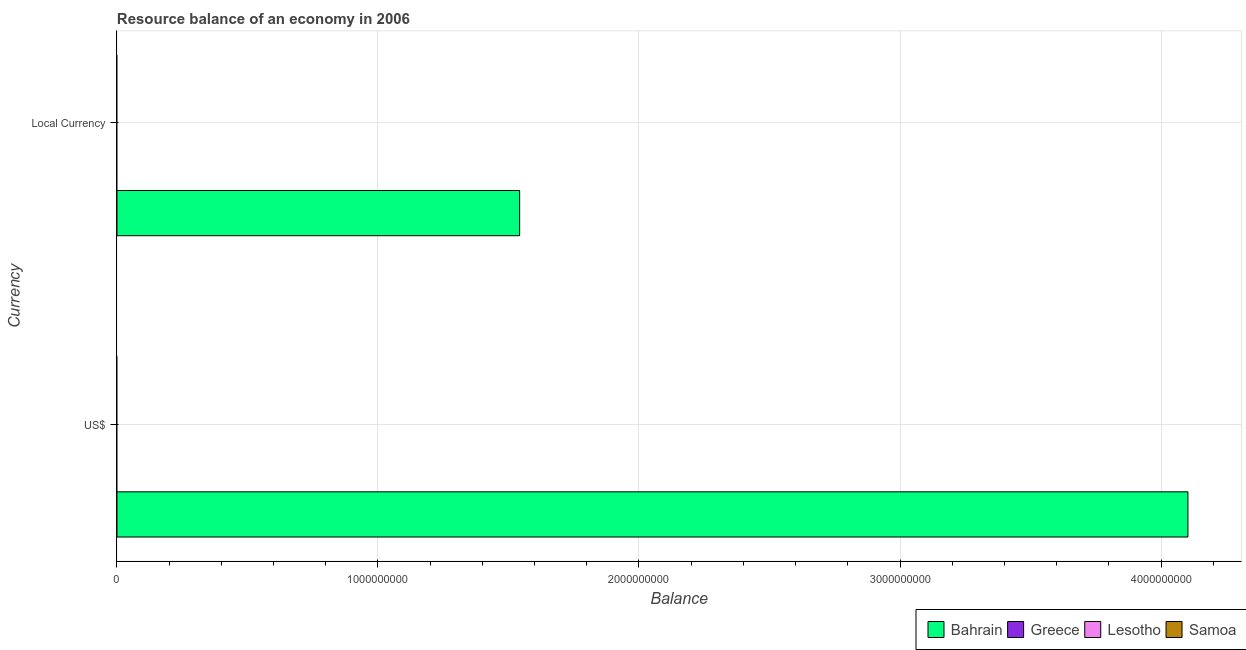How many different coloured bars are there?
Offer a terse response. 1. Are the number of bars on each tick of the Y-axis equal?
Your answer should be very brief. Yes. What is the label of the 1st group of bars from the top?
Make the answer very short. Local Currency. What is the resource balance in constant us$ in Greece?
Make the answer very short. 0. Across all countries, what is the maximum resource balance in constant us$?
Ensure brevity in your answer.  1.54e+09. Across all countries, what is the minimum resource balance in constant us$?
Keep it short and to the point. 0. In which country was the resource balance in us$ maximum?
Ensure brevity in your answer.  Bahrain. What is the total resource balance in us$ in the graph?
Your response must be concise. 4.10e+09. What is the difference between the resource balance in us$ in Greece and the resource balance in constant us$ in Bahrain?
Offer a very short reply. -1.54e+09. What is the average resource balance in us$ per country?
Ensure brevity in your answer.  1.03e+09. What is the difference between the resource balance in constant us$ and resource balance in us$ in Bahrain?
Ensure brevity in your answer.  -2.56e+09. In how many countries, is the resource balance in us$ greater than 3200000000 units?
Your response must be concise. 1. In how many countries, is the resource balance in constant us$ greater than the average resource balance in constant us$ taken over all countries?
Ensure brevity in your answer.  1. How many bars are there?
Provide a succinct answer. 2. Are all the bars in the graph horizontal?
Your answer should be compact. Yes. How many countries are there in the graph?
Offer a very short reply. 4. What is the difference between two consecutive major ticks on the X-axis?
Offer a terse response. 1.00e+09. Does the graph contain any zero values?
Ensure brevity in your answer.  Yes. Where does the legend appear in the graph?
Keep it short and to the point. Bottom right. What is the title of the graph?
Make the answer very short. Resource balance of an economy in 2006. What is the label or title of the X-axis?
Keep it short and to the point. Balance. What is the label or title of the Y-axis?
Your answer should be very brief. Currency. What is the Balance of Bahrain in US$?
Ensure brevity in your answer.  4.10e+09. What is the Balance in Greece in US$?
Your answer should be very brief. 0. What is the Balance in Lesotho in US$?
Offer a terse response. 0. What is the Balance of Samoa in US$?
Your response must be concise. 0. What is the Balance in Bahrain in Local Currency?
Your answer should be very brief. 1.54e+09. What is the Balance of Greece in Local Currency?
Offer a terse response. 0. What is the Balance in Lesotho in Local Currency?
Offer a very short reply. 0. Across all Currency, what is the maximum Balance of Bahrain?
Provide a succinct answer. 4.10e+09. Across all Currency, what is the minimum Balance of Bahrain?
Make the answer very short. 1.54e+09. What is the total Balance in Bahrain in the graph?
Your answer should be very brief. 5.65e+09. What is the total Balance of Greece in the graph?
Make the answer very short. 0. What is the total Balance of Lesotho in the graph?
Keep it short and to the point. 0. What is the total Balance of Samoa in the graph?
Your answer should be very brief. 0. What is the difference between the Balance in Bahrain in US$ and that in Local Currency?
Your response must be concise. 2.56e+09. What is the average Balance of Bahrain per Currency?
Your answer should be very brief. 2.82e+09. What is the average Balance of Greece per Currency?
Provide a succinct answer. 0. What is the ratio of the Balance of Bahrain in US$ to that in Local Currency?
Make the answer very short. 2.66. What is the difference between the highest and the second highest Balance of Bahrain?
Ensure brevity in your answer.  2.56e+09. What is the difference between the highest and the lowest Balance in Bahrain?
Keep it short and to the point. 2.56e+09. 